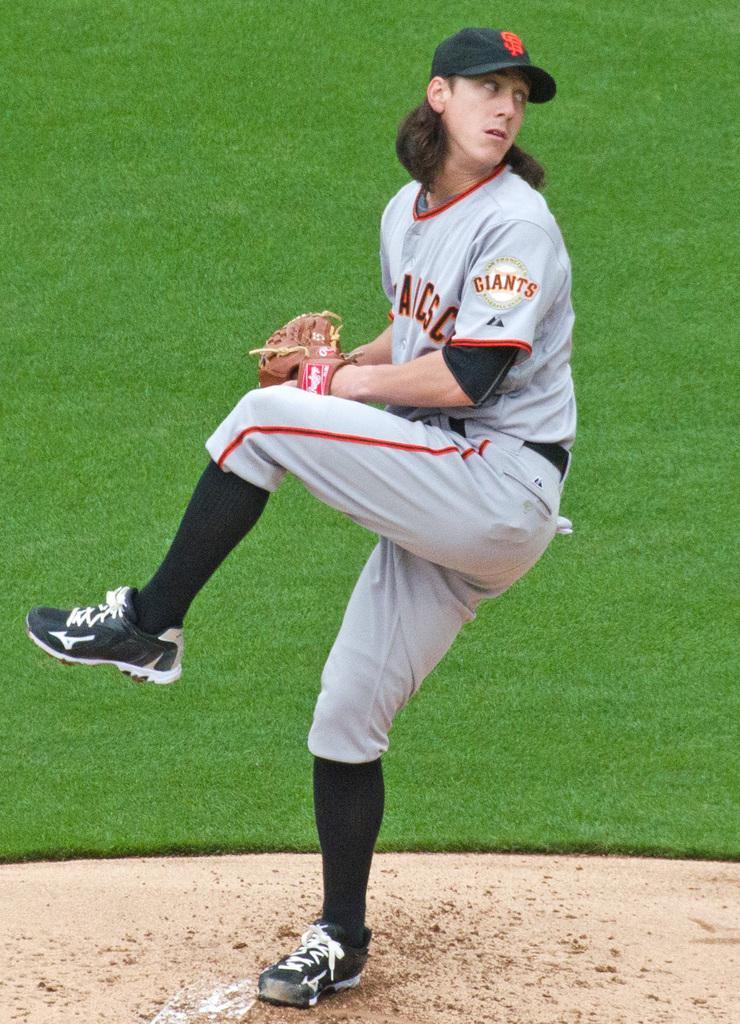Can you describe this image briefly? In this image we can see a person standing on the ground and the person is wearing a cap. Behind the person we can see the grassy land. 